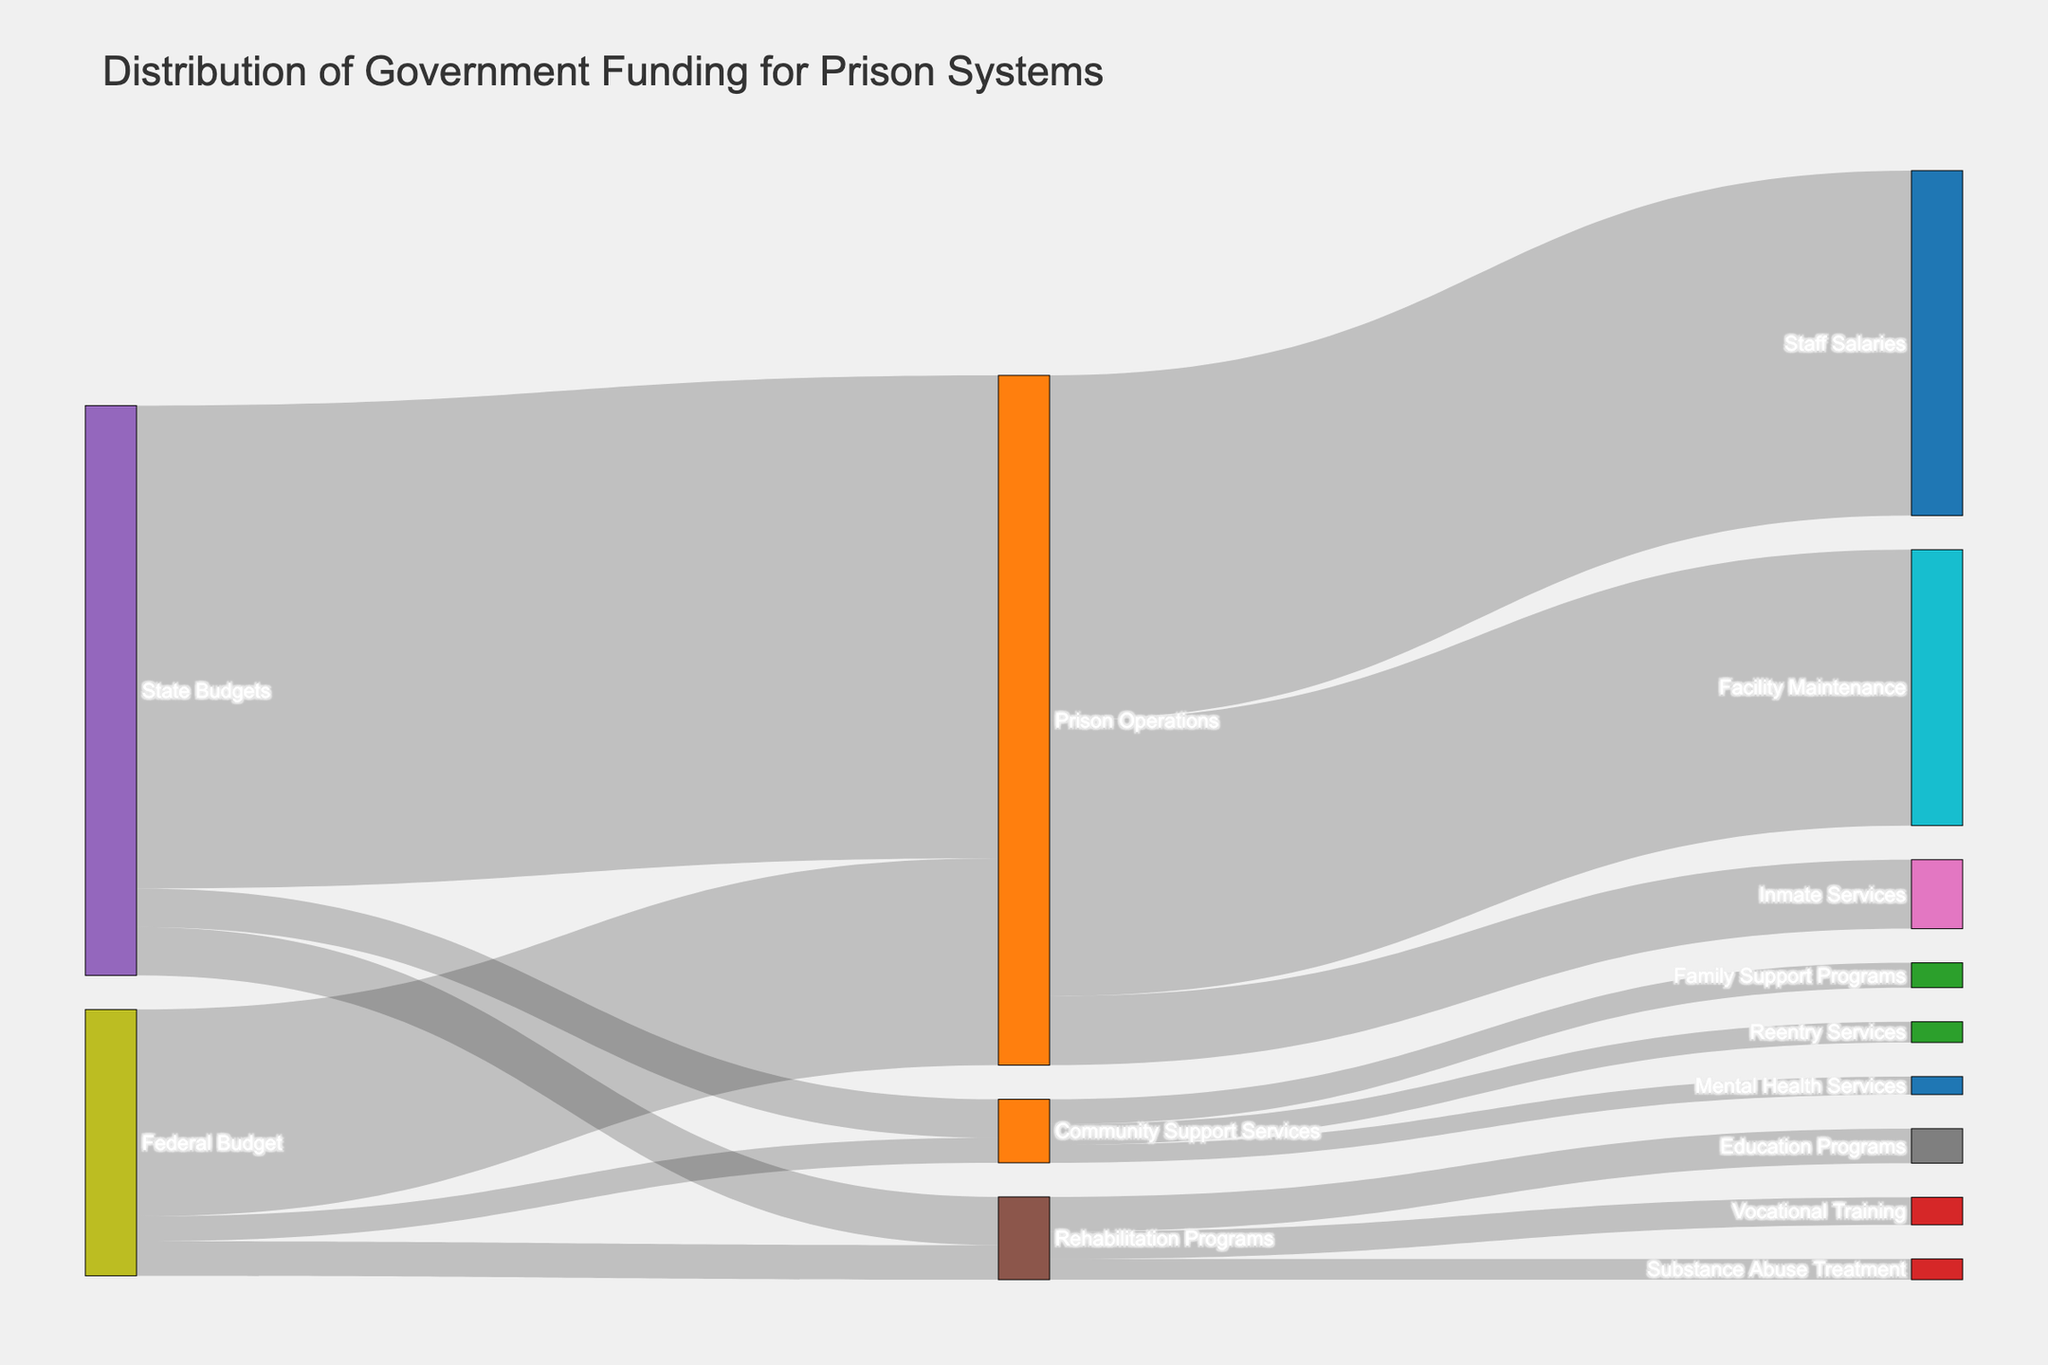How much funding does the Federal Budget allocate to Prison Operations? The Sankey diagram shows different funding sources and allocations. From the Federal Budget, the line leading to Prison Operations indicates the amount allocated.
Answer: 15 billion dollars What is the total funding allocated by the State Budgets? To find the total allocation from State Budgets, sum the values allocated to Prison Operations, Rehabilitation Programs, and Community Support Services.
Answer: 35 billion + 3.5 billion + 2.8 billion = 41.3 billion dollars Which category receives more funding from the Federal Budget: Rehabilitation Programs or Community Support Services? Compare the values from the Federal Budget to both Rehabilitation Programs and Community Support Services.
Answer: Rehabilitation Programs How much money is allocated to Inmate Services from Prison Operations? Trace the line from Prison Operations leading to Inmate Services to find the funding amount.
Answer: 5 billion dollars What is the total funding allocated to Rehabilitation Programs in all levels of government? Sum the funds allocated to Rehabilitation Programs from Federal and State Budgets.
Answer: 2.5 billion + 3.5 billion = 6 billion dollars Which specific program in Community Support Services receives the highest funding? Examine all the sub-categories under Community Support Services and compare their funding amounts.
Answer: Family Support Programs How does the funding for Substance Abuse Treatment compare to Education Programs under Rehabilitation Programs? Compare the respective allocations for both Substance Abuse Treatment and Education Programs within Rehabilitation Programs.
Answer: Education Programs receive more funding What percentage of the total funding from the Federal Budget is allocated to Community Support Services? Divide the funding for Community Support Services by the total Federal Budget allocation and multiply by 100. (1.8B / (15B + 2.5B + 1.8B)) * 100
Answer: 8.3% How does the funding for Staff Salaries compare to Facility Maintenance under Prison Operations? Compare the respective allocations for Staff Salaries and Facility Maintenance within Prison Operations.
Answer: Staff Salaries receive 5 billion more What is the proportion of funding for Reentry Services relative to the total allocation for Community Support Services? Divide the funding for Reentry Services by the total funding for Community Support Services and multiply by 100. (1.5B / (1.8B + 1.5B + 1.3B))
Answer: 26.79% 